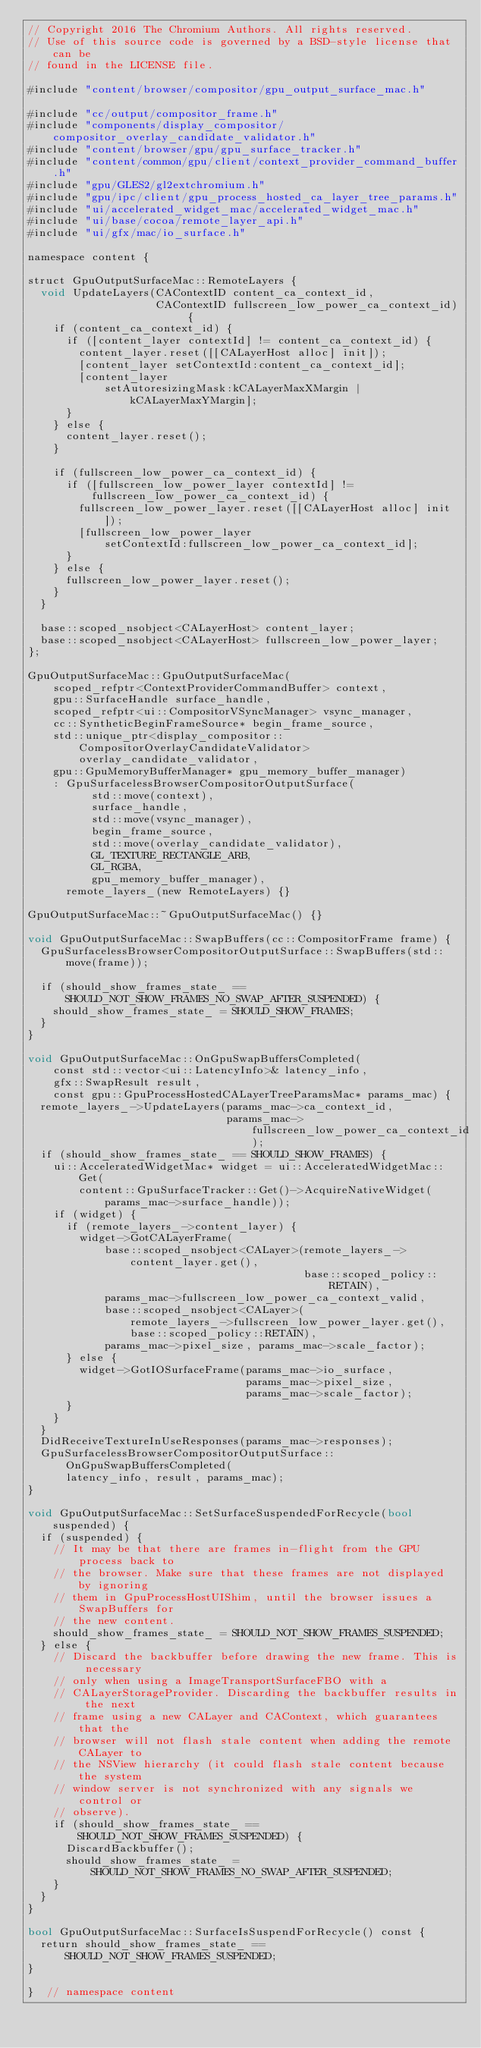Convert code to text. <code><loc_0><loc_0><loc_500><loc_500><_ObjectiveC_>// Copyright 2016 The Chromium Authors. All rights reserved.
// Use of this source code is governed by a BSD-style license that can be
// found in the LICENSE file.

#include "content/browser/compositor/gpu_output_surface_mac.h"

#include "cc/output/compositor_frame.h"
#include "components/display_compositor/compositor_overlay_candidate_validator.h"
#include "content/browser/gpu/gpu_surface_tracker.h"
#include "content/common/gpu/client/context_provider_command_buffer.h"
#include "gpu/GLES2/gl2extchromium.h"
#include "gpu/ipc/client/gpu_process_hosted_ca_layer_tree_params.h"
#include "ui/accelerated_widget_mac/accelerated_widget_mac.h"
#include "ui/base/cocoa/remote_layer_api.h"
#include "ui/gfx/mac/io_surface.h"

namespace content {

struct GpuOutputSurfaceMac::RemoteLayers {
  void UpdateLayers(CAContextID content_ca_context_id,
                    CAContextID fullscreen_low_power_ca_context_id) {
    if (content_ca_context_id) {
      if ([content_layer contextId] != content_ca_context_id) {
        content_layer.reset([[CALayerHost alloc] init]);
        [content_layer setContextId:content_ca_context_id];
        [content_layer
            setAutoresizingMask:kCALayerMaxXMargin | kCALayerMaxYMargin];
      }
    } else {
      content_layer.reset();
    }

    if (fullscreen_low_power_ca_context_id) {
      if ([fullscreen_low_power_layer contextId] !=
          fullscreen_low_power_ca_context_id) {
        fullscreen_low_power_layer.reset([[CALayerHost alloc] init]);
        [fullscreen_low_power_layer
            setContextId:fullscreen_low_power_ca_context_id];
      }
    } else {
      fullscreen_low_power_layer.reset();
    }
  }

  base::scoped_nsobject<CALayerHost> content_layer;
  base::scoped_nsobject<CALayerHost> fullscreen_low_power_layer;
};

GpuOutputSurfaceMac::GpuOutputSurfaceMac(
    scoped_refptr<ContextProviderCommandBuffer> context,
    gpu::SurfaceHandle surface_handle,
    scoped_refptr<ui::CompositorVSyncManager> vsync_manager,
    cc::SyntheticBeginFrameSource* begin_frame_source,
    std::unique_ptr<display_compositor::CompositorOverlayCandidateValidator>
        overlay_candidate_validator,
    gpu::GpuMemoryBufferManager* gpu_memory_buffer_manager)
    : GpuSurfacelessBrowserCompositorOutputSurface(
          std::move(context),
          surface_handle,
          std::move(vsync_manager),
          begin_frame_source,
          std::move(overlay_candidate_validator),
          GL_TEXTURE_RECTANGLE_ARB,
          GL_RGBA,
          gpu_memory_buffer_manager),
      remote_layers_(new RemoteLayers) {}

GpuOutputSurfaceMac::~GpuOutputSurfaceMac() {}

void GpuOutputSurfaceMac::SwapBuffers(cc::CompositorFrame frame) {
  GpuSurfacelessBrowserCompositorOutputSurface::SwapBuffers(std::move(frame));

  if (should_show_frames_state_ ==
      SHOULD_NOT_SHOW_FRAMES_NO_SWAP_AFTER_SUSPENDED) {
    should_show_frames_state_ = SHOULD_SHOW_FRAMES;
  }
}

void GpuOutputSurfaceMac::OnGpuSwapBuffersCompleted(
    const std::vector<ui::LatencyInfo>& latency_info,
    gfx::SwapResult result,
    const gpu::GpuProcessHostedCALayerTreeParamsMac* params_mac) {
  remote_layers_->UpdateLayers(params_mac->ca_context_id,
                               params_mac->fullscreen_low_power_ca_context_id);
  if (should_show_frames_state_ == SHOULD_SHOW_FRAMES) {
    ui::AcceleratedWidgetMac* widget = ui::AcceleratedWidgetMac::Get(
        content::GpuSurfaceTracker::Get()->AcquireNativeWidget(
            params_mac->surface_handle));
    if (widget) {
      if (remote_layers_->content_layer) {
        widget->GotCALayerFrame(
            base::scoped_nsobject<CALayer>(remote_layers_->content_layer.get(),
                                           base::scoped_policy::RETAIN),
            params_mac->fullscreen_low_power_ca_context_valid,
            base::scoped_nsobject<CALayer>(
                remote_layers_->fullscreen_low_power_layer.get(),
                base::scoped_policy::RETAIN),
            params_mac->pixel_size, params_mac->scale_factor);
      } else {
        widget->GotIOSurfaceFrame(params_mac->io_surface,
                                  params_mac->pixel_size,
                                  params_mac->scale_factor);
      }
    }
  }
  DidReceiveTextureInUseResponses(params_mac->responses);
  GpuSurfacelessBrowserCompositorOutputSurface::OnGpuSwapBuffersCompleted(
      latency_info, result, params_mac);
}

void GpuOutputSurfaceMac::SetSurfaceSuspendedForRecycle(bool suspended) {
  if (suspended) {
    // It may be that there are frames in-flight from the GPU process back to
    // the browser. Make sure that these frames are not displayed by ignoring
    // them in GpuProcessHostUIShim, until the browser issues a SwapBuffers for
    // the new content.
    should_show_frames_state_ = SHOULD_NOT_SHOW_FRAMES_SUSPENDED;
  } else {
    // Discard the backbuffer before drawing the new frame. This is necessary
    // only when using a ImageTransportSurfaceFBO with a
    // CALayerStorageProvider. Discarding the backbuffer results in the next
    // frame using a new CALayer and CAContext, which guarantees that the
    // browser will not flash stale content when adding the remote CALayer to
    // the NSView hierarchy (it could flash stale content because the system
    // window server is not synchronized with any signals we control or
    // observe).
    if (should_show_frames_state_ == SHOULD_NOT_SHOW_FRAMES_SUSPENDED) {
      DiscardBackbuffer();
      should_show_frames_state_ =
          SHOULD_NOT_SHOW_FRAMES_NO_SWAP_AFTER_SUSPENDED;
    }
  }
}

bool GpuOutputSurfaceMac::SurfaceIsSuspendForRecycle() const {
  return should_show_frames_state_ == SHOULD_NOT_SHOW_FRAMES_SUSPENDED;
}

}  // namespace content
</code> 